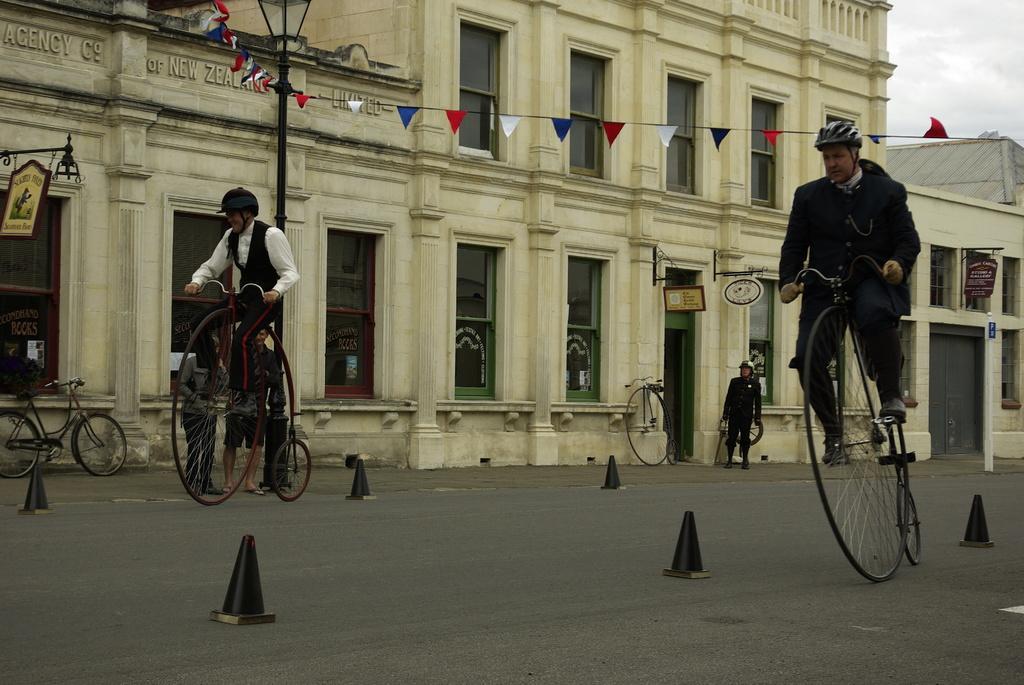Can you describe this image briefly? There are two man riding unicycle and behind them there is a building and at one corner there is a man standing. 